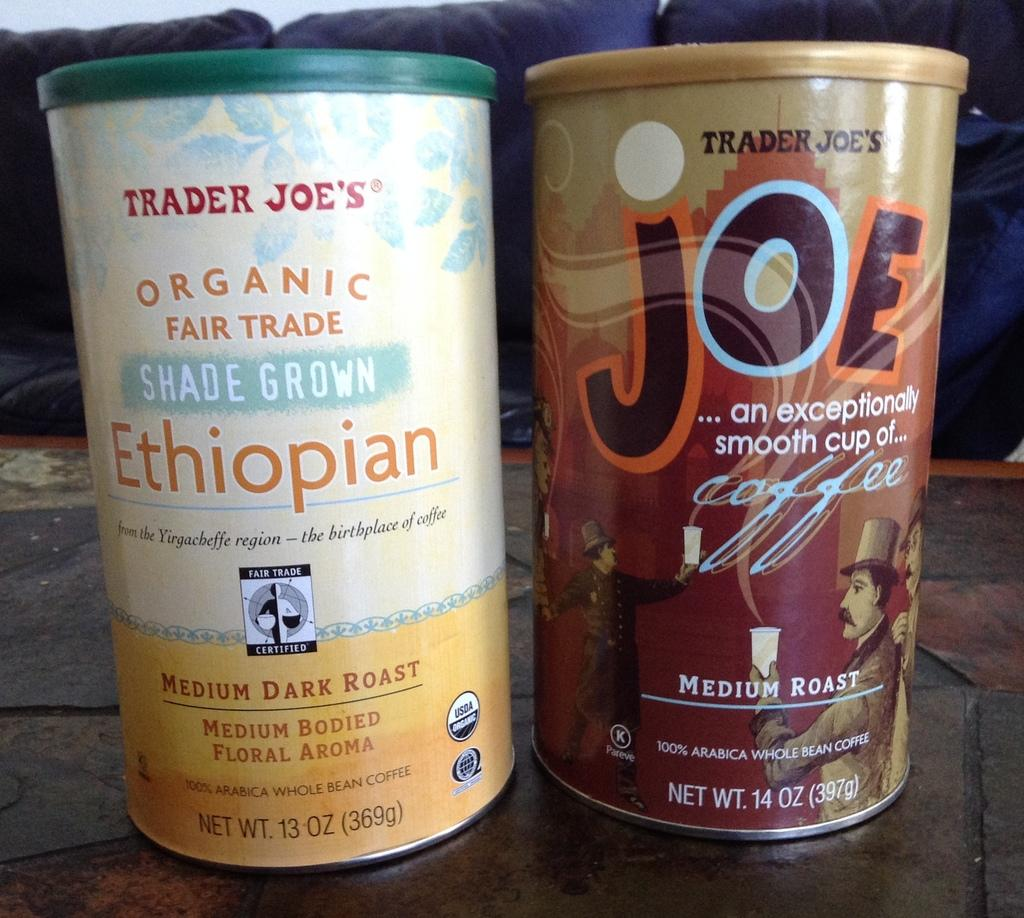<image>
Write a terse but informative summary of the picture. the word Joe that is on some container 